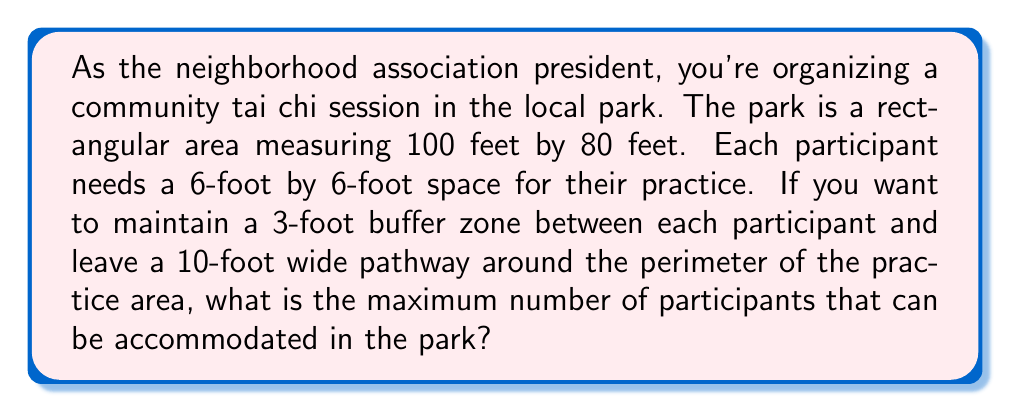Provide a solution to this math problem. Let's approach this step-by-step:

1) First, calculate the available space for the tai chi practice:
   - Park dimensions: 100 feet × 80 feet
   - Pathway width: 10 feet on each side
   - Available space: $(100 - 2 \times 10)$ feet × $(80 - 2 \times 10)$ feet
   - Available space: $80$ feet × $60$ feet

2) Calculate the space needed for each participant:
   - Practice space: 6 feet × 6 feet
   - Buffer zone: 3 feet on each side
   - Total space per participant: $(6 + 2 \times 3)$ feet × $(6 + 2 \times 3)$ feet
   - Total space per participant: $12$ feet × $12$ feet

3) Calculate the number of participants that can fit in each dimension:
   - In the 80-foot dimension: $\lfloor \frac{80}{12} \rfloor = 6$ participants
   - In the 60-foot dimension: $\lfloor \frac{60}{12} \rfloor = 5$ participants

4) Calculate the total number of participants:
   - Maximum number of participants = $6 \times 5 = 30$

This arrangement can be visualized as:

[asy]
size(200);
draw((0,0)--(80,0)--(80,60)--(0,60)--cycle);
for(int i=0; i<6; ++i)
  for(int j=0; j<5; ++j)
    draw((i*12+3,j*12+3)--(i*12+9,j*12+3)--(i*12+9,j*12+9)--(i*12+3,j*12+9)--cycle);
label("80 ft", (40,-5));
label("60 ft", (-5,30), W);
[/asy]

Therefore, the maximum number of participants that can be accommodated is 30.
Answer: 30 participants 